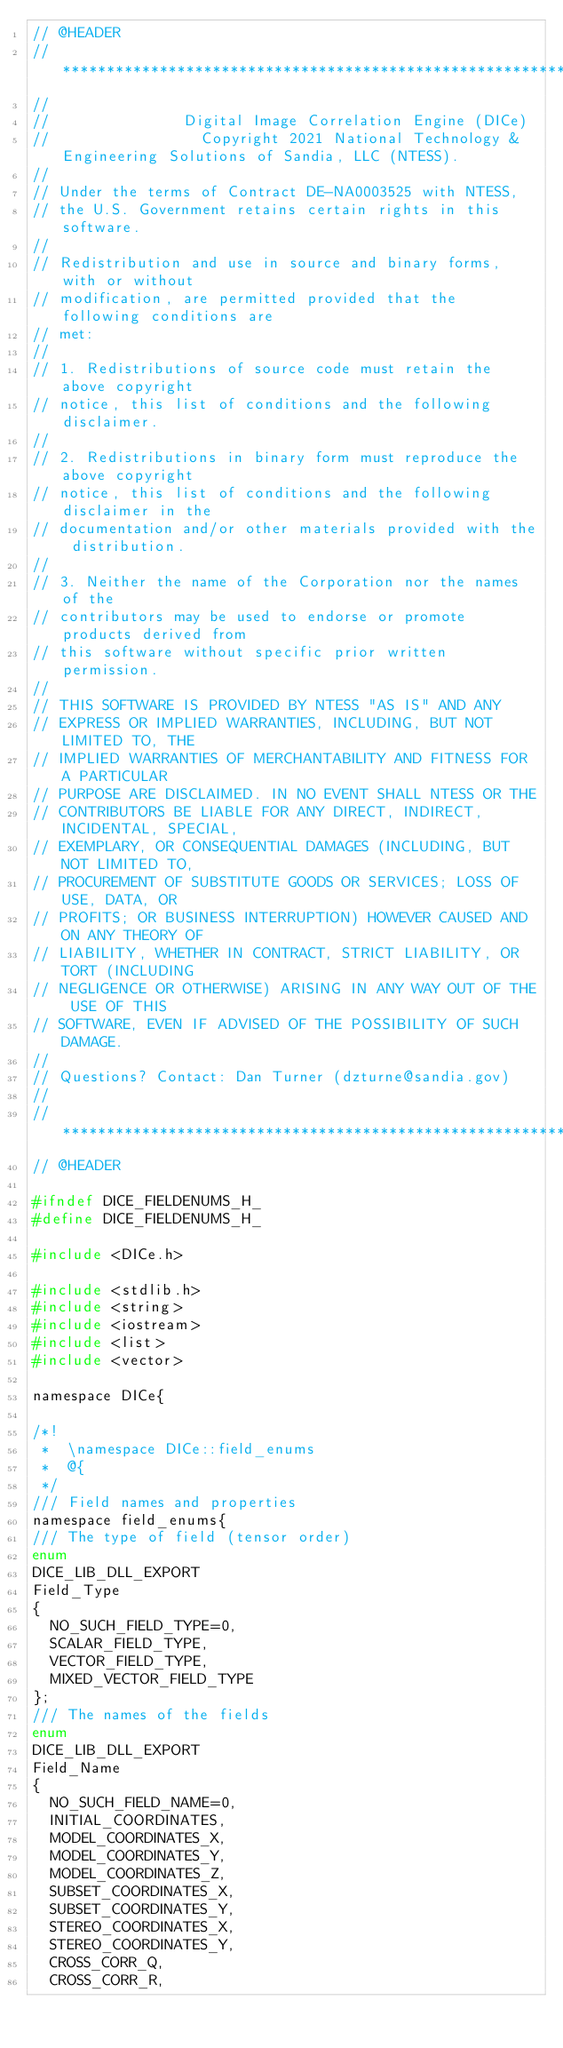Convert code to text. <code><loc_0><loc_0><loc_500><loc_500><_C_>// @HEADER
// ************************************************************************
//
//               Digital Image Correlation Engine (DICe)
//                 Copyright 2021 National Technology & Engineering Solutions of Sandia, LLC (NTESS).
//
// Under the terms of Contract DE-NA0003525 with NTESS,
// the U.S. Government retains certain rights in this software.
//
// Redistribution and use in source and binary forms, with or without
// modification, are permitted provided that the following conditions are
// met:
//
// 1. Redistributions of source code must retain the above copyright
// notice, this list of conditions and the following disclaimer.
//
// 2. Redistributions in binary form must reproduce the above copyright
// notice, this list of conditions and the following disclaimer in the
// documentation and/or other materials provided with the distribution.
//
// 3. Neither the name of the Corporation nor the names of the
// contributors may be used to endorse or promote products derived from
// this software without specific prior written permission.
//
// THIS SOFTWARE IS PROVIDED BY NTESS "AS IS" AND ANY
// EXPRESS OR IMPLIED WARRANTIES, INCLUDING, BUT NOT LIMITED TO, THE
// IMPLIED WARRANTIES OF MERCHANTABILITY AND FITNESS FOR A PARTICULAR
// PURPOSE ARE DISCLAIMED. IN NO EVENT SHALL NTESS OR THE
// CONTRIBUTORS BE LIABLE FOR ANY DIRECT, INDIRECT, INCIDENTAL, SPECIAL,
// EXEMPLARY, OR CONSEQUENTIAL DAMAGES (INCLUDING, BUT NOT LIMITED TO,
// PROCUREMENT OF SUBSTITUTE GOODS OR SERVICES; LOSS OF USE, DATA, OR
// PROFITS; OR BUSINESS INTERRUPTION) HOWEVER CAUSED AND ON ANY THEORY OF
// LIABILITY, WHETHER IN CONTRACT, STRICT LIABILITY, OR TORT (INCLUDING
// NEGLIGENCE OR OTHERWISE) ARISING IN ANY WAY OUT OF THE USE OF THIS
// SOFTWARE, EVEN IF ADVISED OF THE POSSIBILITY OF SUCH DAMAGE.
//
// Questions? Contact: Dan Turner (dzturne@sandia.gov)
//
// ************************************************************************
// @HEADER

#ifndef DICE_FIELDENUMS_H_
#define DICE_FIELDENUMS_H_

#include <DICe.h>

#include <stdlib.h>
#include <string>
#include <iostream>
#include <list>
#include <vector>

namespace DICe{

/*!
 *  \namespace DICe::field_enums
 *  @{
 */
/// Field names and properties
namespace field_enums{
/// The type of field (tensor order)
enum
DICE_LIB_DLL_EXPORT
Field_Type
{
  NO_SUCH_FIELD_TYPE=0,
  SCALAR_FIELD_TYPE,
  VECTOR_FIELD_TYPE,
  MIXED_VECTOR_FIELD_TYPE
};
/// The names of the fields
enum
DICE_LIB_DLL_EXPORT
Field_Name
{
  NO_SUCH_FIELD_NAME=0,
  INITIAL_COORDINATES,
  MODEL_COORDINATES_X,
  MODEL_COORDINATES_Y,
  MODEL_COORDINATES_Z,
  SUBSET_COORDINATES_X,
  SUBSET_COORDINATES_Y,
  STEREO_COORDINATES_X,
  STEREO_COORDINATES_Y,
  CROSS_CORR_Q,
  CROSS_CORR_R,</code> 